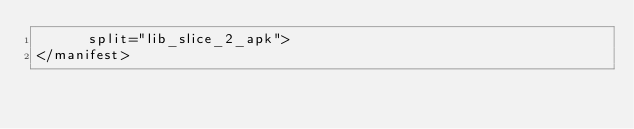Convert code to text. <code><loc_0><loc_0><loc_500><loc_500><_XML_>      split="lib_slice_2_apk">
</manifest>
</code> 